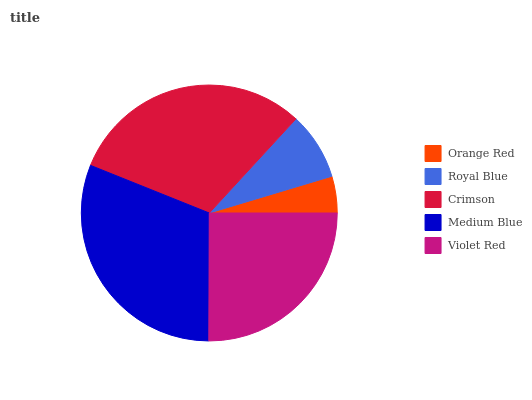Is Orange Red the minimum?
Answer yes or no. Yes. Is Medium Blue the maximum?
Answer yes or no. Yes. Is Royal Blue the minimum?
Answer yes or no. No. Is Royal Blue the maximum?
Answer yes or no. No. Is Royal Blue greater than Orange Red?
Answer yes or no. Yes. Is Orange Red less than Royal Blue?
Answer yes or no. Yes. Is Orange Red greater than Royal Blue?
Answer yes or no. No. Is Royal Blue less than Orange Red?
Answer yes or no. No. Is Violet Red the high median?
Answer yes or no. Yes. Is Violet Red the low median?
Answer yes or no. Yes. Is Orange Red the high median?
Answer yes or no. No. Is Crimson the low median?
Answer yes or no. No. 